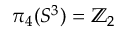Convert formula to latex. <formula><loc_0><loc_0><loc_500><loc_500>\pi _ { 4 } ( S ^ { 3 } ) = \mathbb { Z } _ { 2 }</formula> 